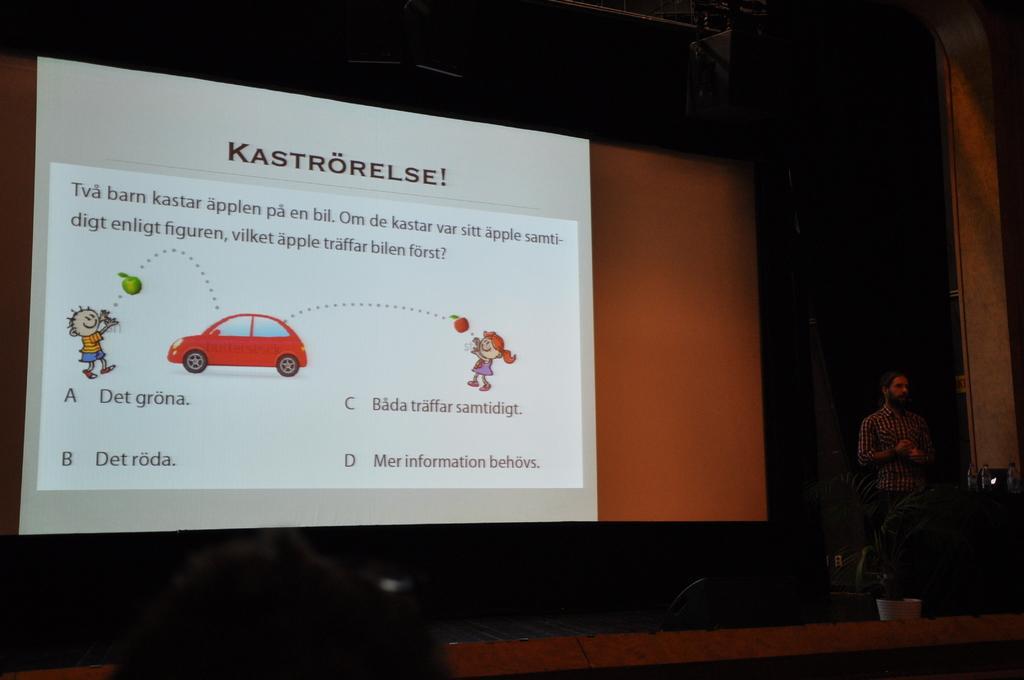Describe this image in one or two sentences. In this picture, we can see a person on a stage, and in the background we can see the screen with some images and some text on it. 